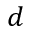<formula> <loc_0><loc_0><loc_500><loc_500>d</formula> 